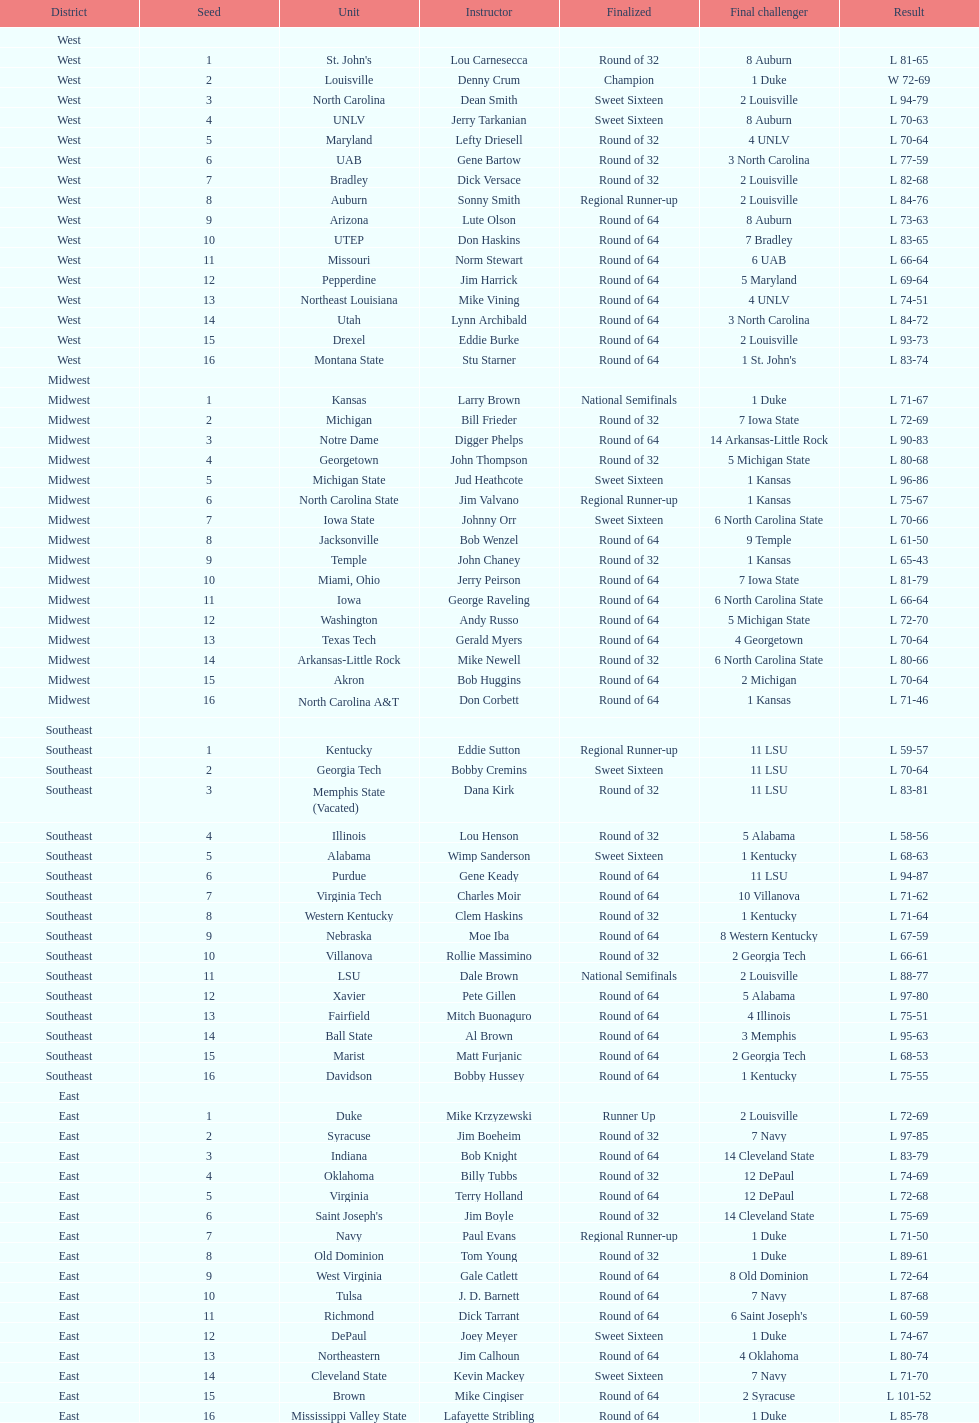What region is listed before the midwest? West. 